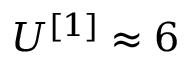<formula> <loc_0><loc_0><loc_500><loc_500>U ^ { [ 1 ] } \approx 6</formula> 